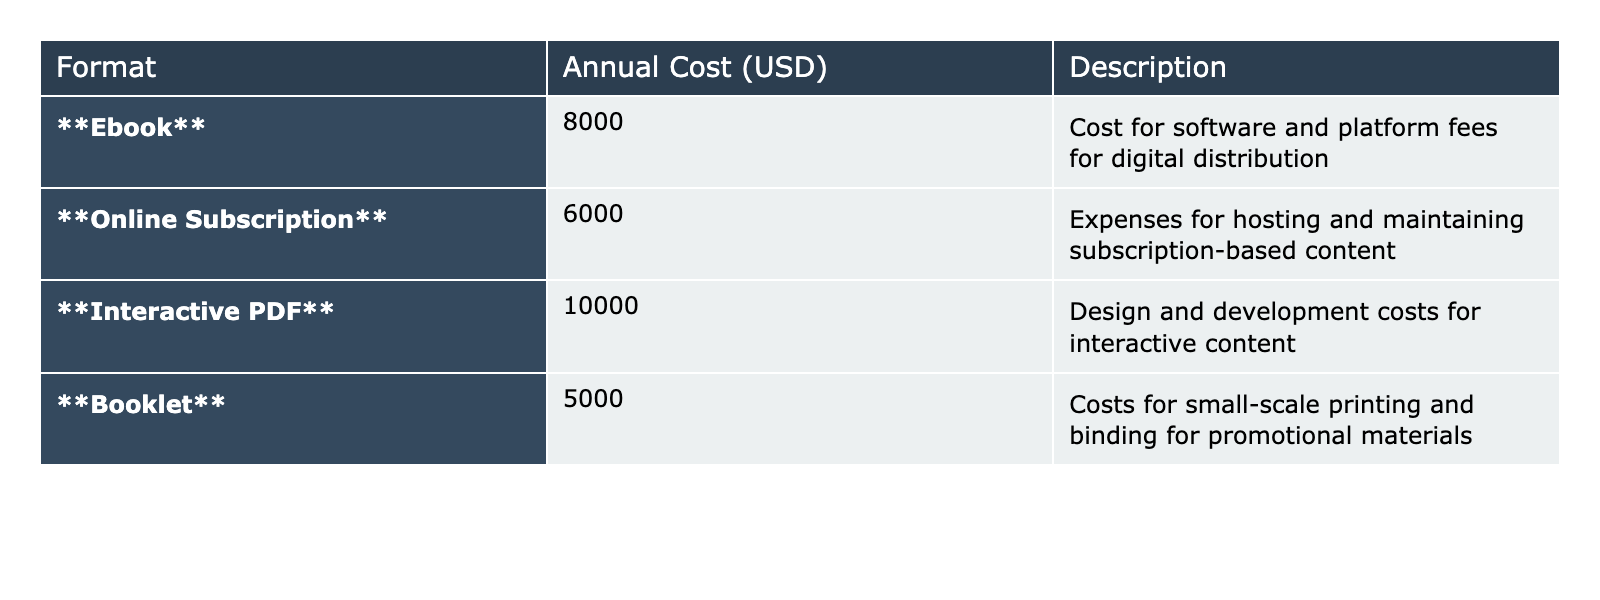What is the annual cost for ebooks? The table lists the annual cost for ebooks as 8000 USD. This value is directly retrieved from the "Annual Cost (USD)" column next to the "Ebook" entry.
Answer: 8000 Which format has the highest annual cost? The "Interactive PDF" format has the highest annual cost of 10000 USD, as seen in the "Annual Cost (USD)" column.
Answer: Interactive PDF What is the total annual cost for all formats combined? To find the total, add the annual costs: 8000 + 6000 + 10000 + 5000 = 30000 USD. The calculation combines the values from the "Annual Cost (USD)" column.
Answer: 30000 Is the annual cost for online subscriptions greater than the cost for booklets? The annual cost for online subscriptions is 6000 USD and for booklets is 5000 USD. Since 6000 is greater than 5000, the statement is true.
Answer: Yes What is the average annual cost across all formats? The average is calculated by summing all format costs (8000 + 6000 + 10000 + 5000 = 30000) and dividing by the number of formats (4). Thus, the average is 30000 / 4 = 7500 USD.
Answer: 7500 What is the difference in annual costs between interactive PDFs and ebooks? The annual cost for interactive PDFs is 10000 USD, while for ebooks it is 8000 USD. The difference is 10000 - 8000 = 2000 USD.
Answer: 2000 Are the costs for ebook and online subscription formats together less than that of interactive PDFs? The combined costs for ebooks (8000 USD) and online subscriptions (6000 USD) are 8000 + 6000 = 14000 USD, which is less than the cost for interactive PDFs (10000 USD). Therefore, the statement is false.
Answer: No Which formats have costs below 7000 USD? Only the "Booklet" and "Online Subscription" formats have costs below 7000 USD, with costs of 5000 USD and 6000 USD respectively, as shown in the table.
Answer: Booklet, Online Subscription What percentage of the total costs is attributed to online subscriptions? Online subscriptions cost 6000 USD, while the total cost is 30000 USD. To find the percentage: (6000 / 30000) * 100 = 20%.
Answer: 20% If we were to eliminate the interactive PDF costs, what would the new total be? Removing the interactive PDF cost (10000 USD) from the total (30000 USD), the new total is 30000 - 10000 = 20000 USD. This new total is the sum of the remaining formats: ebooks, online subscriptions, and booklets.
Answer: 20000 